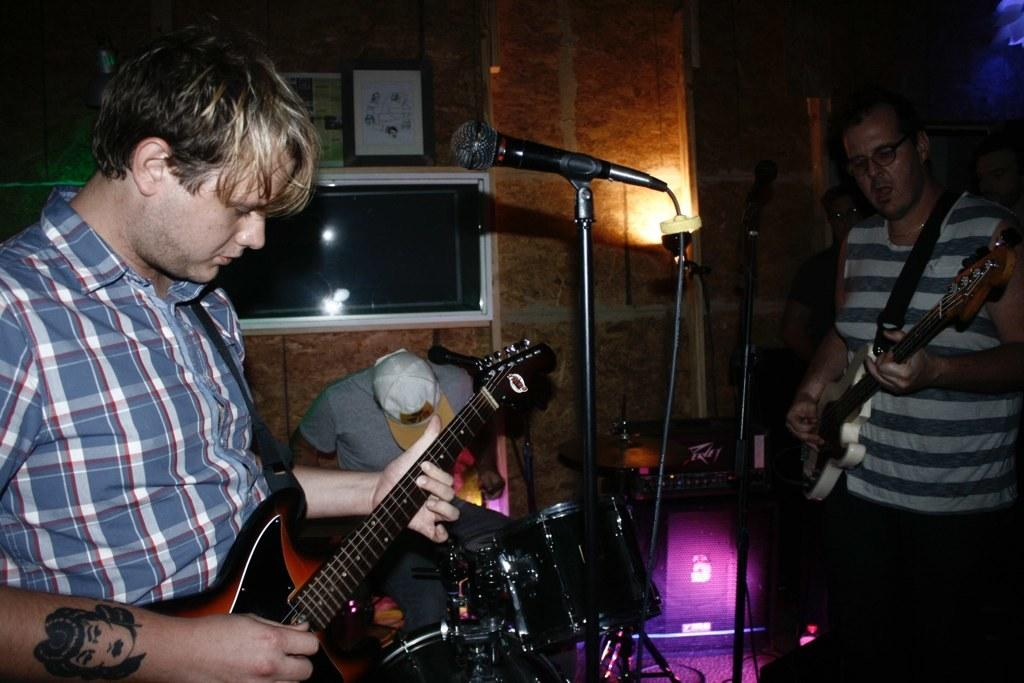How many people are playing musical instruments in the image? There are three persons playing musical instruments in the image. What can be seen in the background of the image? There is a screen, a frame, and a wall in the background of the image. What type of wax is visible on the frame in the background? There is no wax visible on the frame in the background; only the frame itself is mentioned. 